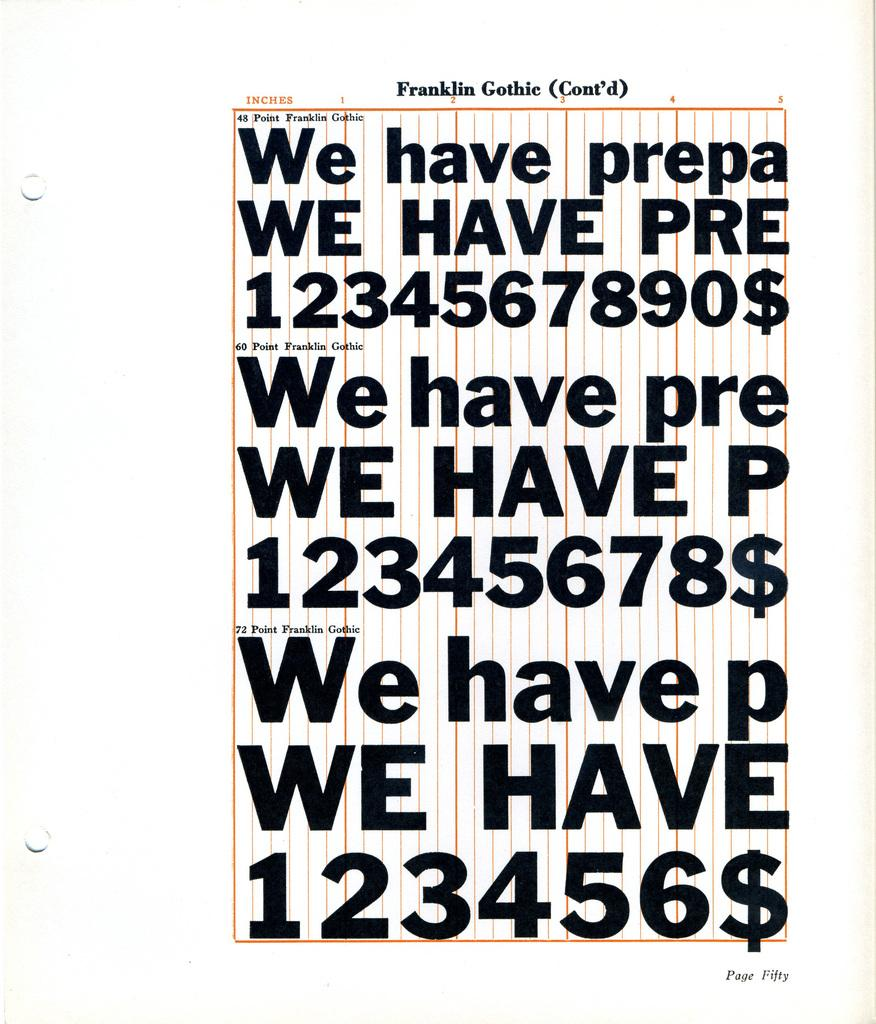<image>
Provide a brief description of the given image. A font called Franklin Gothic is displayed in different sizes 